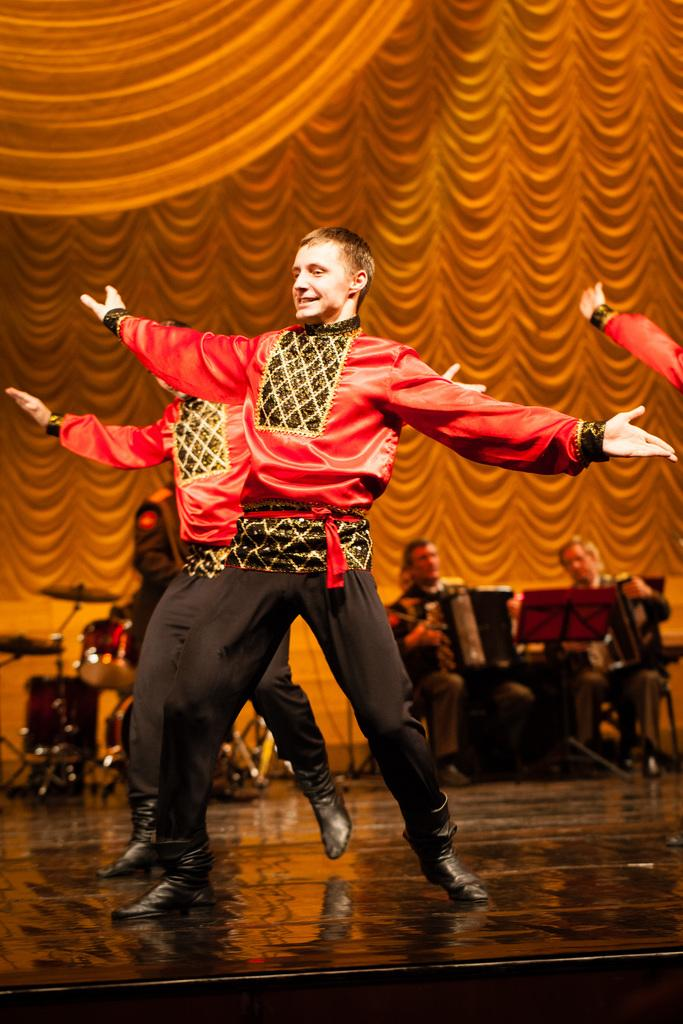What is happening on the stage in the image? There are people on the stage in the image. What are the people on the stage doing? The presence of musical instruments suggests that they might be performing music. What can be seen in the background of the image? There is a curtain in the background of the image. How much debt do the people on the stage have in the image? There is no information about the people's debt in the image, as it focuses on their performance on stage. 